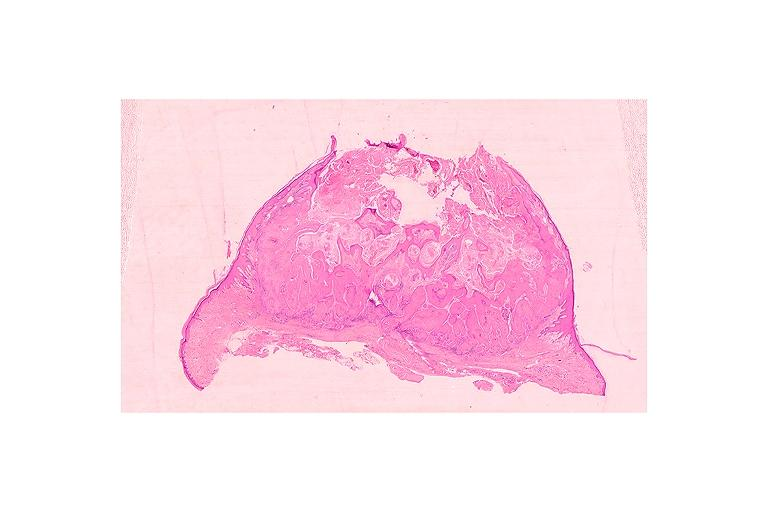s hemorrhage in newborn present?
Answer the question using a single word or phrase. No 